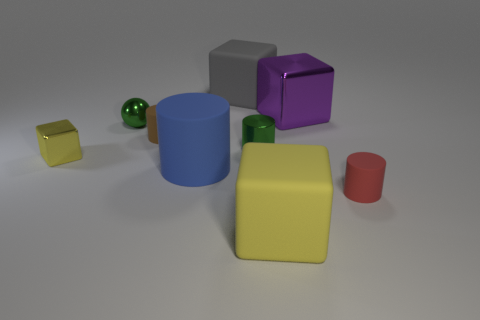Subtract all rubber cylinders. How many cylinders are left? 1 Subtract all gray blocks. How many blocks are left? 3 Subtract 3 cylinders. How many cylinders are left? 1 Subtract all blocks. How many objects are left? 5 Subtract all purple cylinders. Subtract all cyan cubes. How many cylinders are left? 4 Subtract all blue cylinders. How many yellow cubes are left? 2 Subtract all gray blocks. Subtract all purple things. How many objects are left? 7 Add 1 big yellow rubber cubes. How many big yellow rubber cubes are left? 2 Add 2 yellow things. How many yellow things exist? 4 Subtract 0 purple cylinders. How many objects are left? 9 